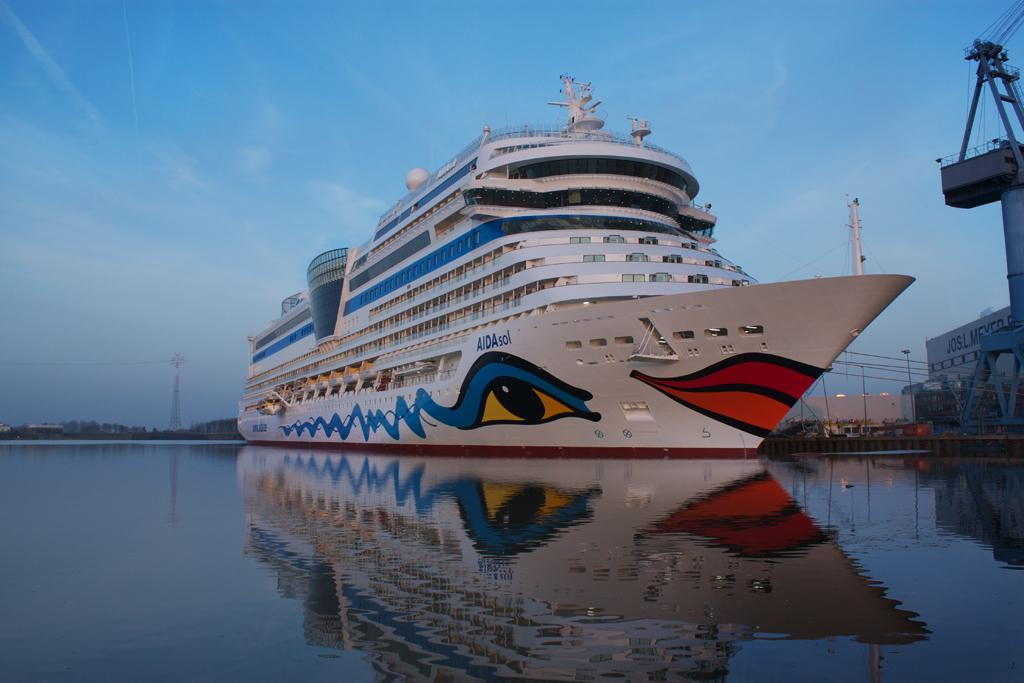What is the main subject of the image? The main subject of the image is a ship. Where is the ship located? The ship is on water. What other structure can be seen in the image? There is a tower in the image. What is visible in the background of the image? The sky is visible in the background of the image. What can be observed in the sky? Clouds are present in the sky. Where is the railway located in the image? There is no railway present in the image. What type of head is visible on the ship in the image? There is no head visible on the ship in the image; it is a vessel for transportation, not a living being. 